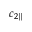<formula> <loc_0><loc_0><loc_500><loc_500>c _ { 2 \| }</formula> 